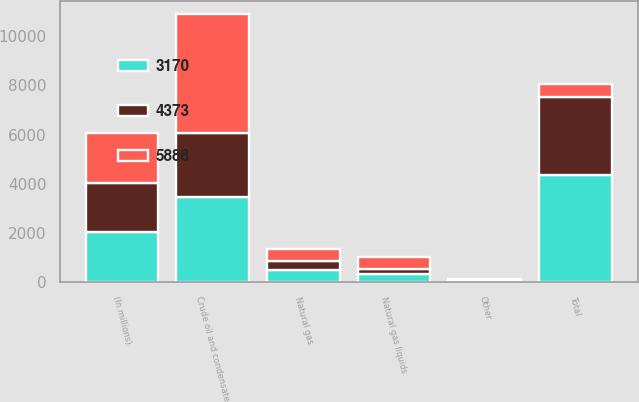Convert chart. <chart><loc_0><loc_0><loc_500><loc_500><stacked_bar_chart><ecel><fcel>(In millions)<fcel>Crude oil and condensate<fcel>Natural gas liquids<fcel>Natural gas<fcel>Other<fcel>Total<nl><fcel>5888<fcel>2018<fcel>4823<fcel>504<fcel>497<fcel>64<fcel>510<nl><fcel>3170<fcel>2017<fcel>3477<fcel>338<fcel>510<fcel>48<fcel>4373<nl><fcel>4373<fcel>2016<fcel>2605<fcel>198<fcel>356<fcel>11<fcel>3170<nl></chart> 